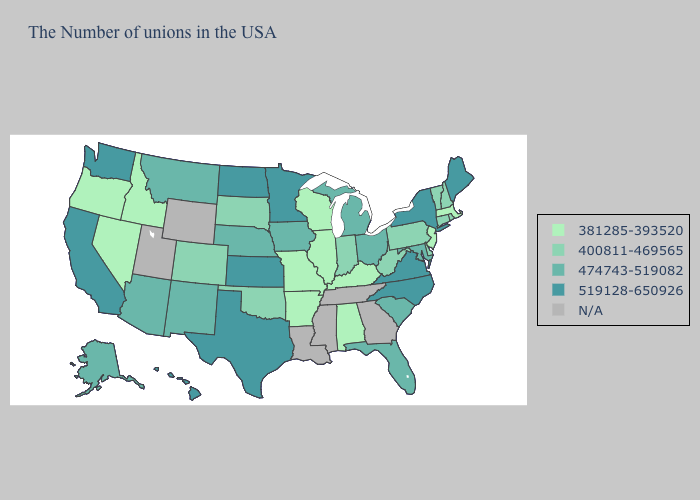What is the value of California?
Be succinct. 519128-650926. Does Massachusetts have the lowest value in the Northeast?
Concise answer only. Yes. What is the highest value in states that border Mississippi?
Give a very brief answer. 381285-393520. Does Kentucky have the highest value in the USA?
Concise answer only. No. Does Massachusetts have the lowest value in the USA?
Quick response, please. Yes. Name the states that have a value in the range 381285-393520?
Quick response, please. Massachusetts, New Jersey, Kentucky, Alabama, Wisconsin, Illinois, Missouri, Arkansas, Idaho, Nevada, Oregon. Which states hav the highest value in the Northeast?
Keep it brief. Maine, New York. What is the value of Kentucky?
Concise answer only. 381285-393520. Name the states that have a value in the range N/A?
Keep it brief. Georgia, Tennessee, Mississippi, Louisiana, Wyoming, Utah. Name the states that have a value in the range N/A?
Answer briefly. Georgia, Tennessee, Mississippi, Louisiana, Wyoming, Utah. What is the value of Utah?
Quick response, please. N/A. Which states have the highest value in the USA?
Concise answer only. Maine, New York, Virginia, North Carolina, Minnesota, Kansas, Texas, North Dakota, California, Washington, Hawaii. Which states have the lowest value in the West?
Give a very brief answer. Idaho, Nevada, Oregon. 